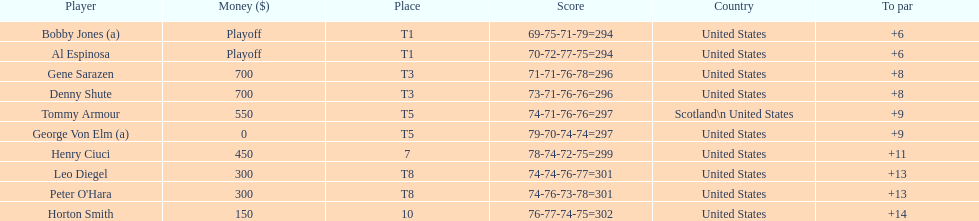What's the count of players who have been part of the scotland squad? 1. 